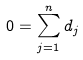Convert formula to latex. <formula><loc_0><loc_0><loc_500><loc_500>0 = \sum _ { j = 1 } ^ { n } d _ { j }</formula> 